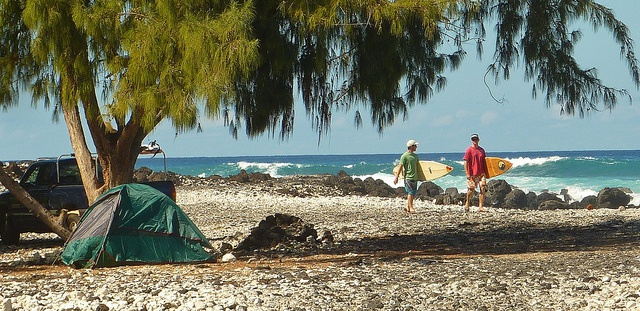Describe the objects in this image and their specific colors. I can see truck in darkgreen, black, gray, and maroon tones, people in darkgreen, maroon, salmon, brown, and tan tones, people in darkgreen, gray, tan, and beige tones, surfboard in darkgreen, khaki, olive, beige, and tan tones, and surfboard in darkgreen, orange, maroon, and red tones in this image. 